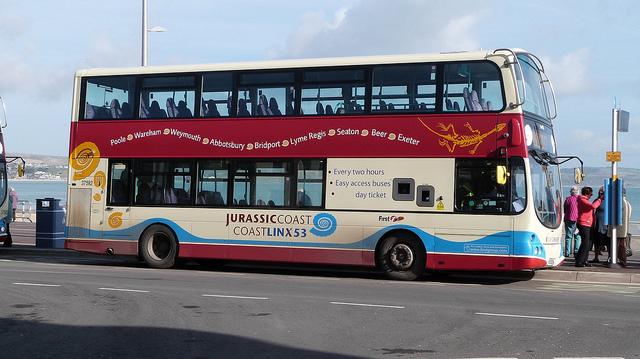Is this a public bus?
Answer briefly. Yes. Is the bus parked on the street?
Be succinct. Yes. How many windows are in the bus?
Keep it brief. 12. What company owns this bus?
Be succinct. Jurassic coast. Is the bus in a parking lot?
Quick response, please. No. What does the sign say on the side of the bus?
Answer briefly. Jurassic coast. What is the road made of?
Give a very brief answer. Asphalt. Is the bus full?
Concise answer only. No. Is this a double decker bus?
Give a very brief answer. Yes. What is the name of the bus company?
Short answer required. Jurassic coast. What are the ingredients in the advertisement on the side of the bus?
Answer briefly. Beer. What water feature is behind the bus?
Quick response, please. Ocean. Is someone standing up on the bus?
Be succinct. No. 